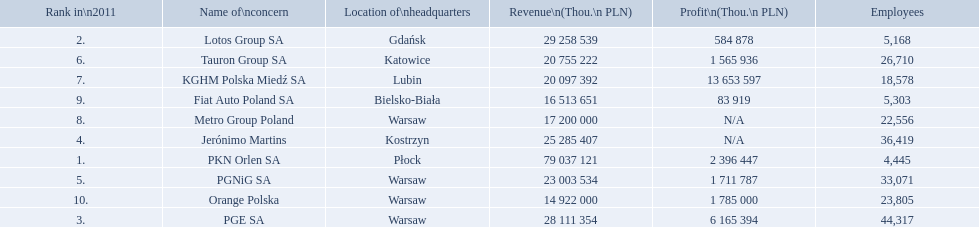What is the number of employees that work for pkn orlen sa in poland? 4,445. What number of employees work for lotos group sa? 5,168. How many people work for pgnig sa? 33,071. What company has 28 111 354 thou.in revenue? PGE SA. What revenue does lotus group sa have? 29 258 539. Who has the next highest revenue than lotus group sa? PKN Orlen SA. 